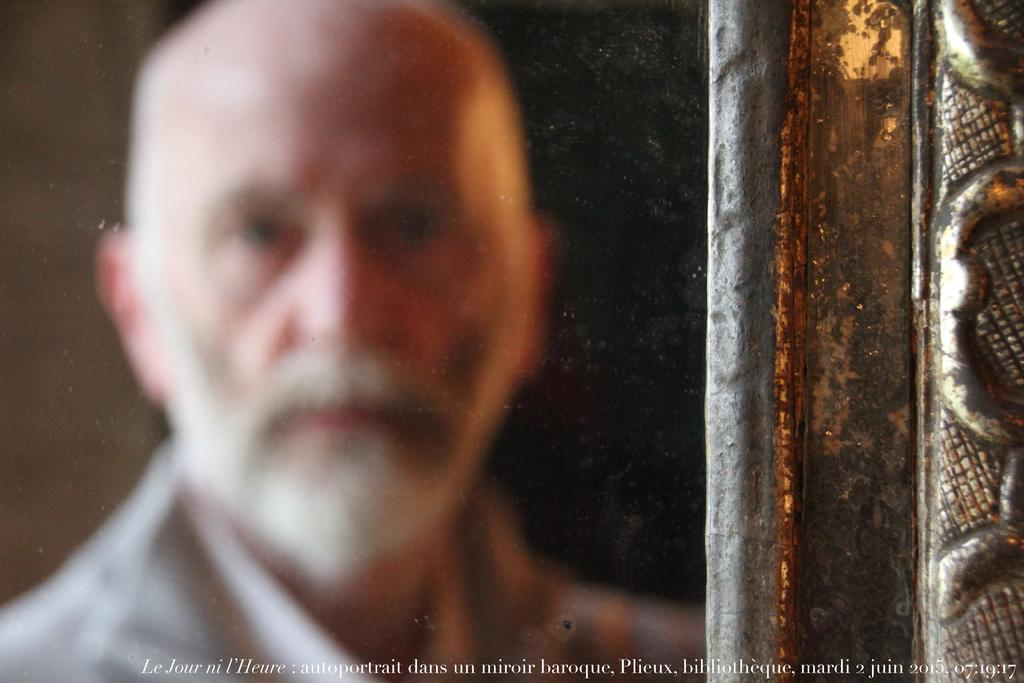What is located on the left side of the image? There is a person on the left side of the image. What can be seen on the right side of the image? There is an object on the right side of the image. What information is provided at the bottom of the image? There is some text written at the bottom of the image. What type of coat is the maid wearing in the image? There is no maid or coat present in the image. What material is the silk used for in the image? There is no silk present in the image. 